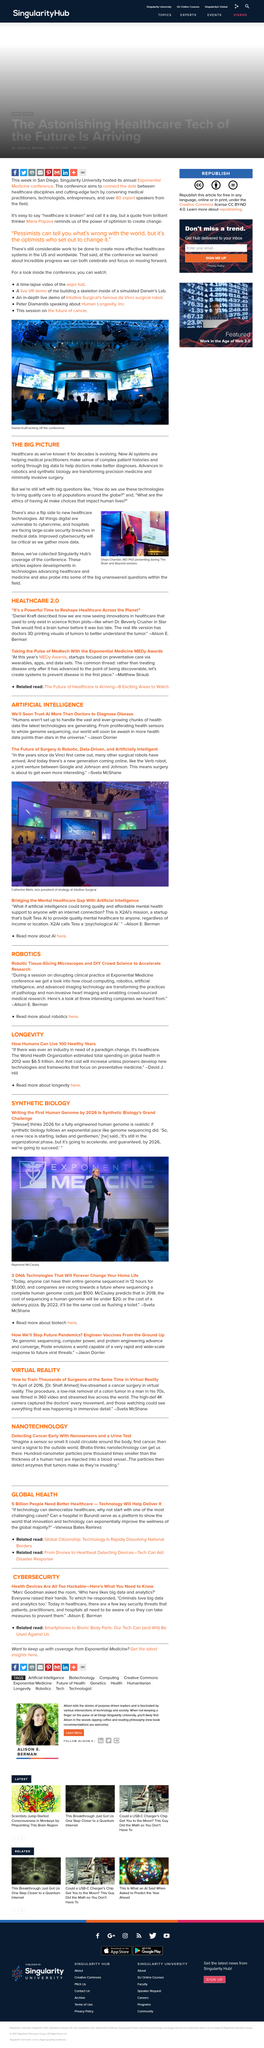Draw attention to some important aspects in this diagram. The person in the photograph is Raymond McCauley. The Verb robot is a member of a cutting-edge class of surgical robots. The "big questions" we are left with after the presentation include "What are the ethics of having AI make choices that impact human lives?" and "How do we use these technologies to bring quality care to all populations around the globe? It is Divya Chander who is depicted in the image. Synthetic biology's grand challenge is to write the first human genome by 2026. 